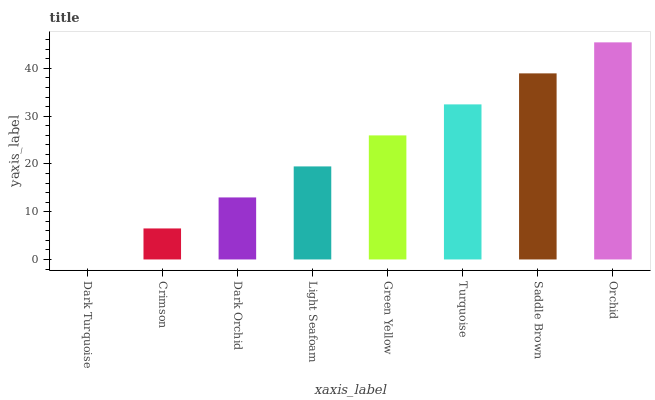Is Dark Turquoise the minimum?
Answer yes or no. Yes. Is Orchid the maximum?
Answer yes or no. Yes. Is Crimson the minimum?
Answer yes or no. No. Is Crimson the maximum?
Answer yes or no. No. Is Crimson greater than Dark Turquoise?
Answer yes or no. Yes. Is Dark Turquoise less than Crimson?
Answer yes or no. Yes. Is Dark Turquoise greater than Crimson?
Answer yes or no. No. Is Crimson less than Dark Turquoise?
Answer yes or no. No. Is Green Yellow the high median?
Answer yes or no. Yes. Is Light Seafoam the low median?
Answer yes or no. Yes. Is Orchid the high median?
Answer yes or no. No. Is Dark Turquoise the low median?
Answer yes or no. No. 